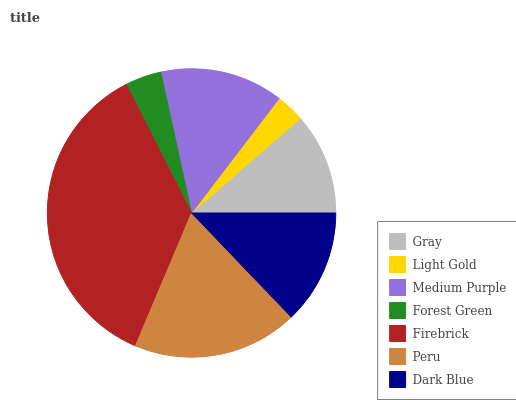Is Light Gold the minimum?
Answer yes or no. Yes. Is Firebrick the maximum?
Answer yes or no. Yes. Is Medium Purple the minimum?
Answer yes or no. No. Is Medium Purple the maximum?
Answer yes or no. No. Is Medium Purple greater than Light Gold?
Answer yes or no. Yes. Is Light Gold less than Medium Purple?
Answer yes or no. Yes. Is Light Gold greater than Medium Purple?
Answer yes or no. No. Is Medium Purple less than Light Gold?
Answer yes or no. No. Is Dark Blue the high median?
Answer yes or no. Yes. Is Dark Blue the low median?
Answer yes or no. Yes. Is Firebrick the high median?
Answer yes or no. No. Is Firebrick the low median?
Answer yes or no. No. 